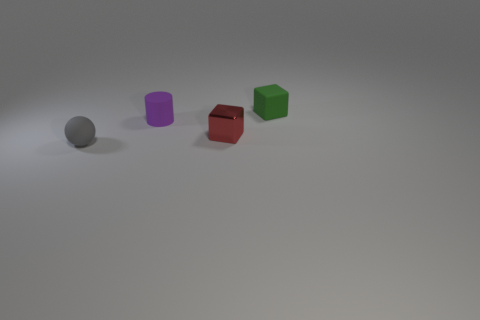Is there any other thing that is the same shape as the purple object?
Provide a short and direct response. No. Does the tiny green object have the same material as the small purple object?
Provide a short and direct response. Yes. Are there any other things that have the same material as the gray thing?
Your answer should be very brief. Yes. There is another green thing that is the same shape as the tiny shiny object; what is its material?
Make the answer very short. Rubber. Are there fewer small gray spheres to the left of the tiny gray thing than tiny green rubber objects?
Give a very brief answer. Yes. How many green things are in front of the gray sphere?
Give a very brief answer. 0. There is a thing that is behind the purple rubber cylinder; is it the same shape as the small matte thing in front of the red metallic object?
Give a very brief answer. No. What shape is the object that is right of the tiny gray ball and in front of the small purple matte thing?
Offer a very short reply. Cube. What is the size of the cylinder that is made of the same material as the gray thing?
Give a very brief answer. Small. Are there fewer tiny metal blocks than gray rubber cubes?
Ensure brevity in your answer.  No. 